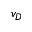<formula> <loc_0><loc_0><loc_500><loc_500>v _ { D }</formula> 